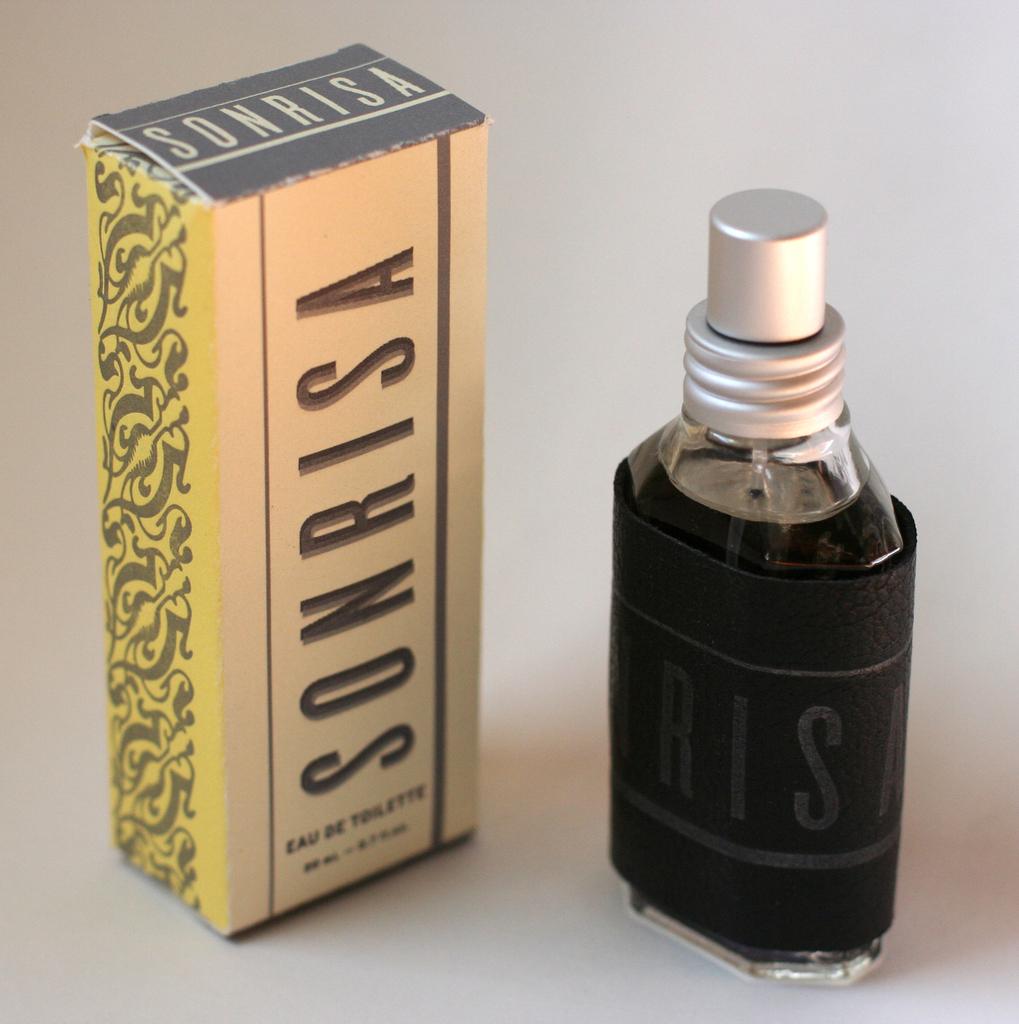Who makes this perfume?
Provide a short and direct response. Sonrisa. 